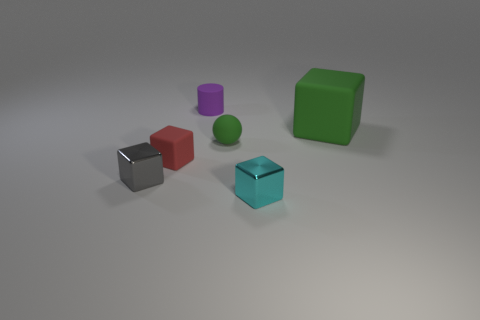Add 4 small gray things. How many objects exist? 10 Subtract all cyan metal blocks. Subtract all red blocks. How many objects are left? 4 Add 5 small matte cubes. How many small matte cubes are left? 6 Add 6 tiny gray metallic balls. How many tiny gray metallic balls exist? 6 Subtract all cyan blocks. How many blocks are left? 3 Subtract all small blocks. How many blocks are left? 1 Subtract 0 blue spheres. How many objects are left? 6 Subtract all spheres. How many objects are left? 5 Subtract 1 cylinders. How many cylinders are left? 0 Subtract all yellow spheres. Subtract all purple cylinders. How many spheres are left? 1 